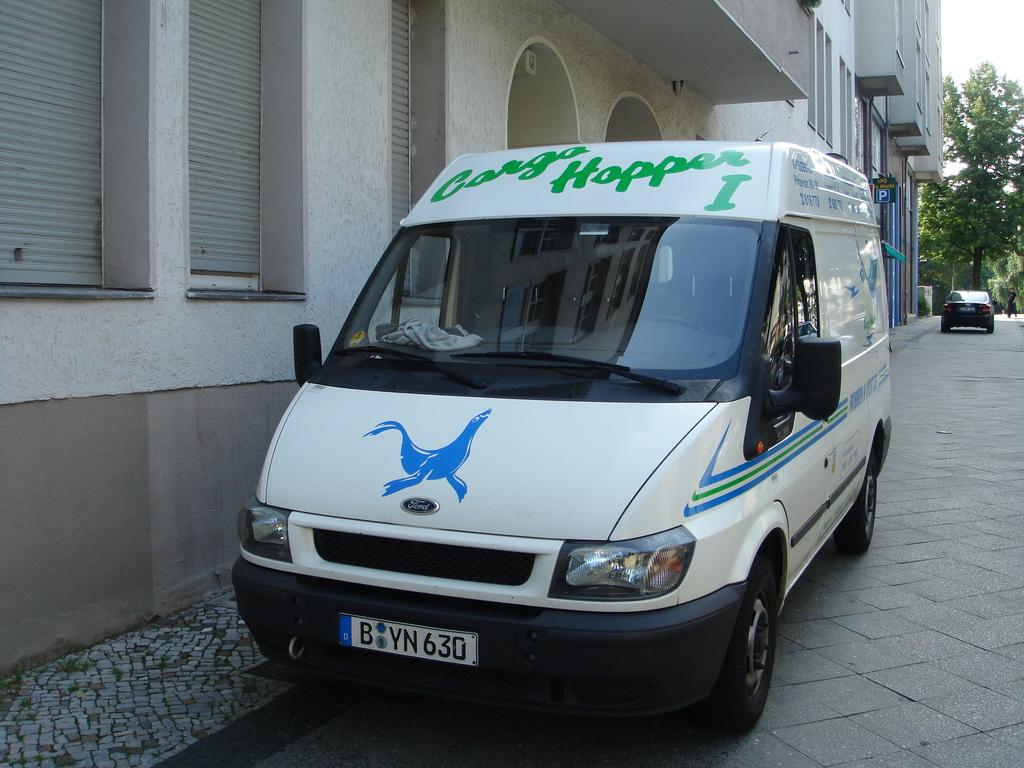<image>
Write a terse but informative summary of the picture. A white van on a street with a blue seal on the front and Cargo Hopper 1 written in green above the front windshield 